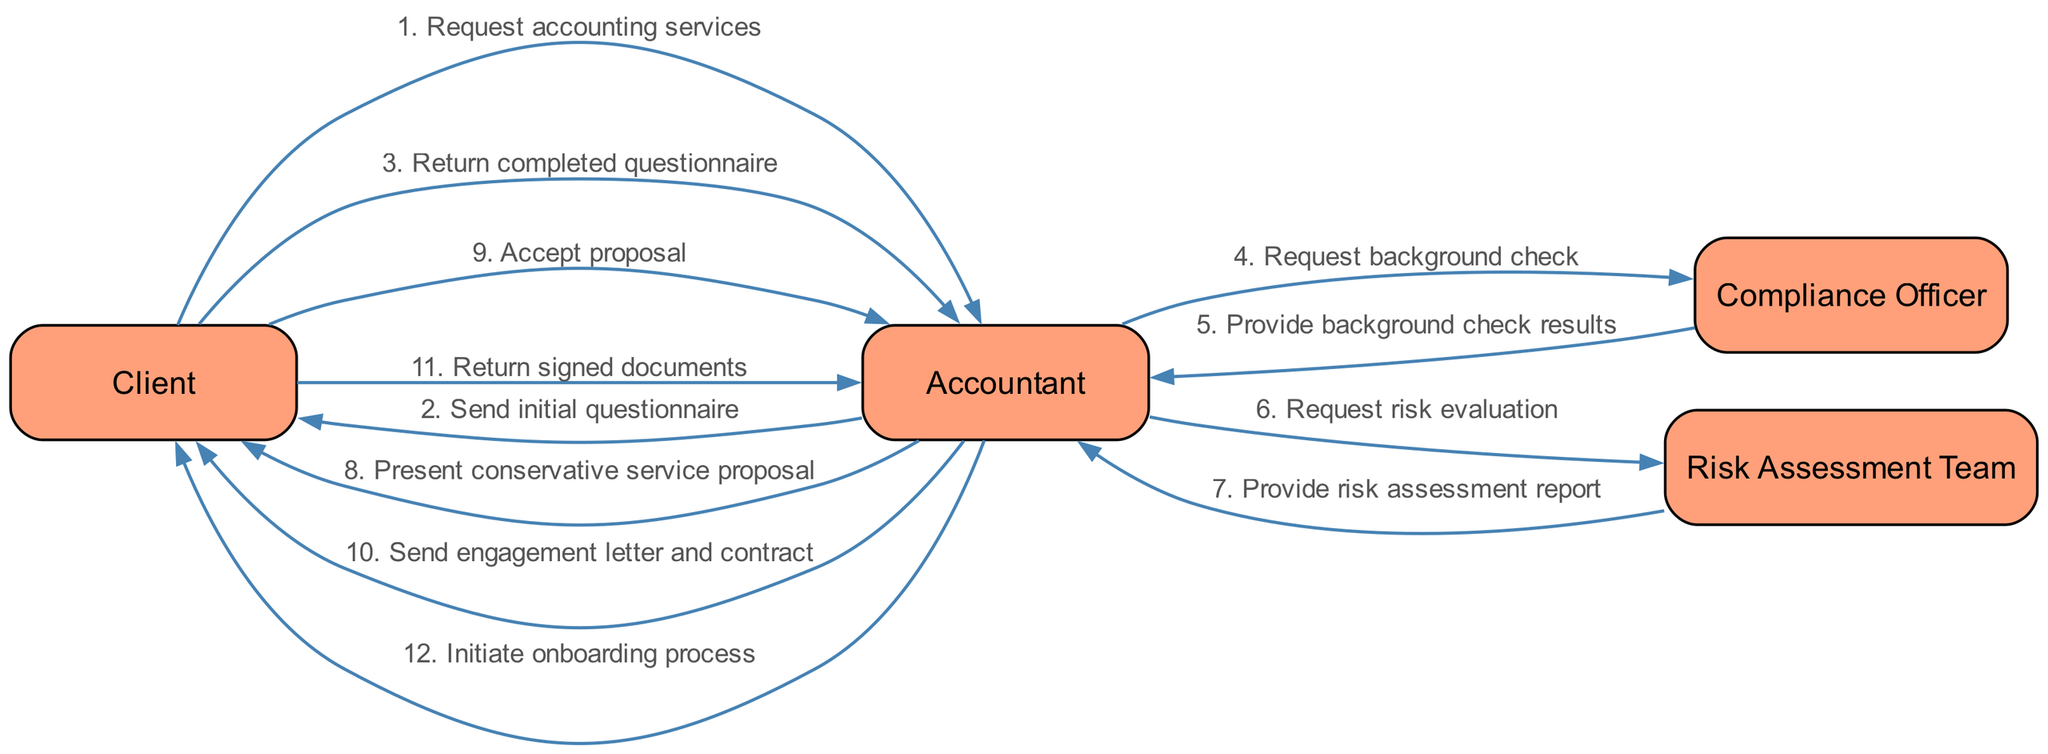What is the first message in the sequence? The first message in the sequence is sent from the Client to the Accountant, and it is "Request accounting services". This can be identified as the very first step in the flow of the diagram.
Answer: Request accounting services How many actors are involved in the process? The diagram includes four actors: Client, Accountant, Compliance Officer, and Risk Assessment Team. This can be determined by counting the distinct participant nodes in the diagram.
Answer: Four What does the Accountant request from the Compliance Officer? The Accountant requests a "background check" from the Compliance Officer, which is specified in the sequence as part of the information flow.
Answer: Background check Which actor presents the service proposal to the Client? The Accountant is responsible for presenting the "conservative service proposal" to the Client, as indicated in the relevant step of the sequence.
Answer: Accountant How many steps are there in the sequence? There are twelve steps in the onboarding process, which can be determined by counting the messages or edges shown in the sequence diagram.
Answer: Twelve What is the final action taken by the Accountant? The final action taken by the Accountant is to "initiate onboarding process", which concludes the sequence flow of messages.
Answer: Initiate onboarding process What does the Client do after receiving the engagement letter and contract? After receiving the engagement letter and contract, the Client returns the "signed documents" to the Accountant, as recorded in the sequence.
Answer: Return signed documents Which team evaluates the risk? The Risk Assessment Team evaluates the risk as requested by the Accountant, which can be seen in the sequence when the Accountant requests a risk evaluation.
Answer: Risk Assessment Team 